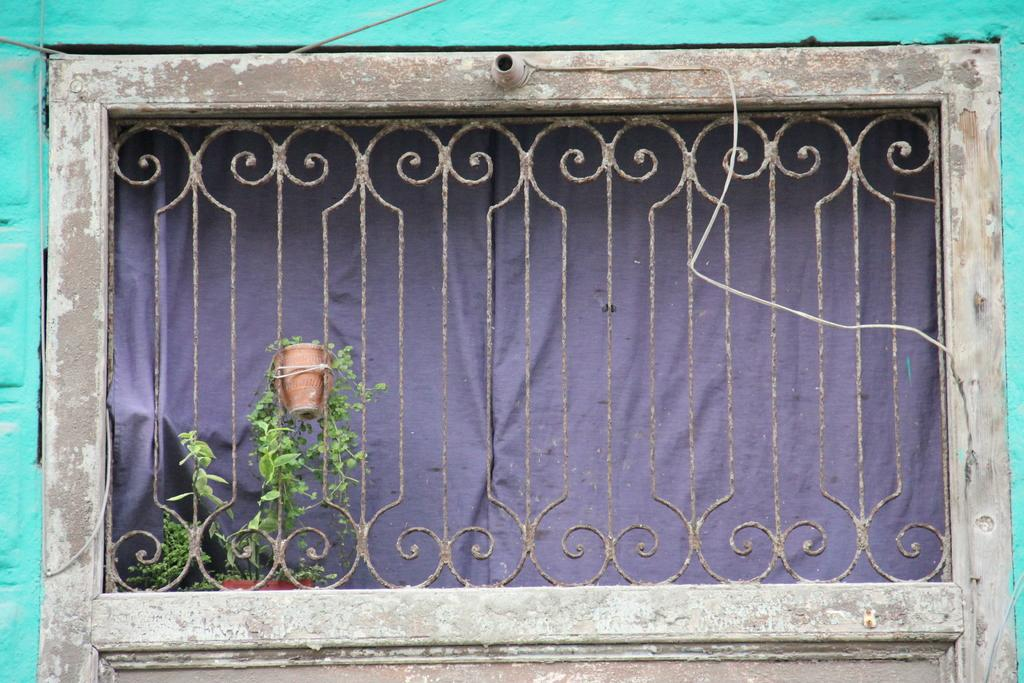What is the main object in the image? There is a grille in the image. What is attached to the grille? A potted plant is attached to the grille. What is attached to the wood in the image? There is a light holder attached to the wood. What can be seen behind the grille? There is a curtain behind the grille. What type of comb is used to style the curtain in the image? There is no comb present in the image, and the curtain is not styled. 